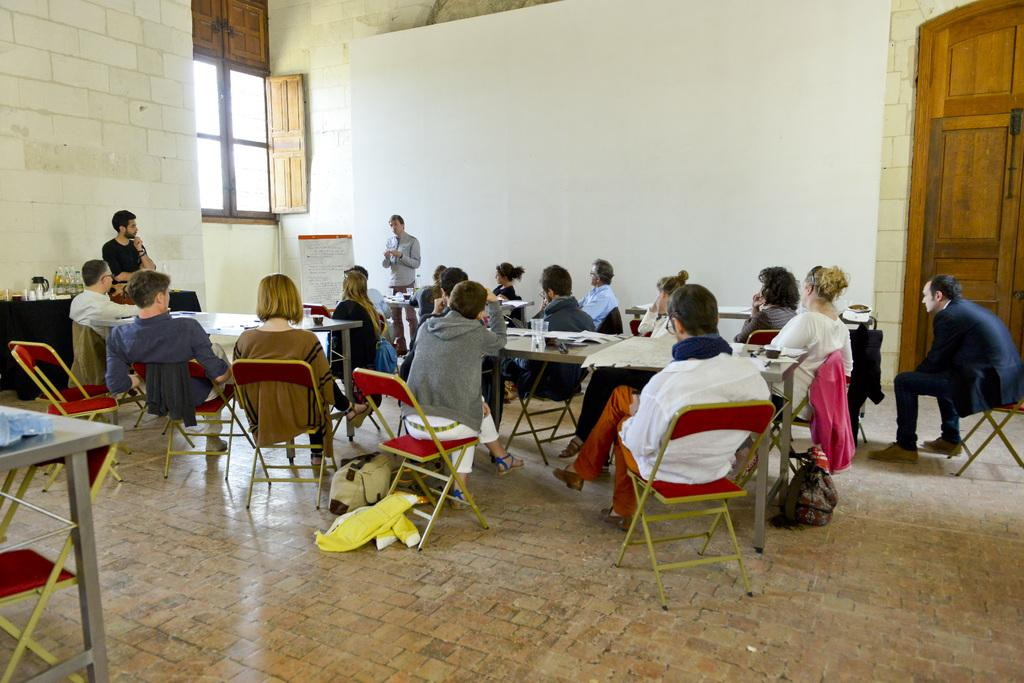What are the people sitting on in the image? There is a group of people sitting in red chairs. What is in front of the group of people? There is a table in front of the group of people. What is on the table? The table has papers on it. What is happening in front of the group of people? There are two persons standing in front of the group of people. Can you tell me how many friends are sitting in the red chairs? The provided facts do not mention any friends in the image; it only states that there is a group of people sitting in red chairs. What type of material is the table made of, and how does it crush the papers? There is no information about the material of the table or any crushing of papers in the image. 